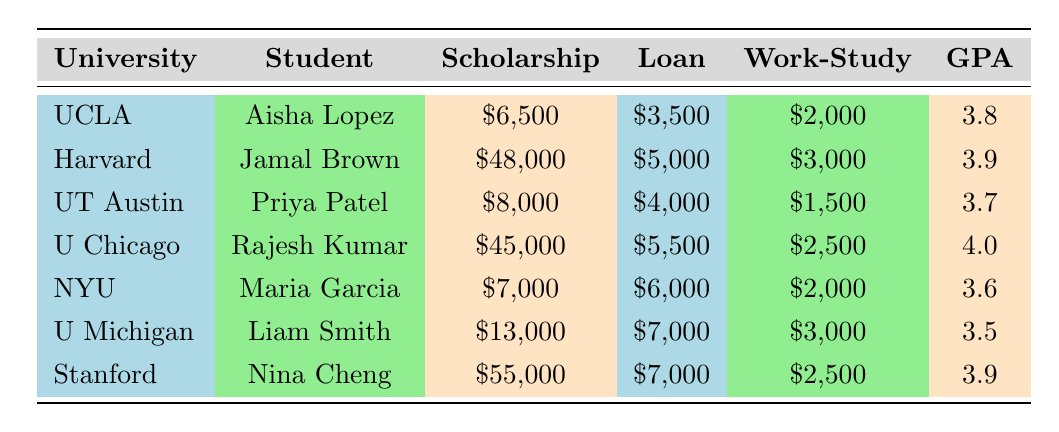What is the total amount of financial aid received by Jamal Brown? The total aid for Jamal Brown is listed in the table under the 'Total Aid' column. It states that he received $56,000.
Answer: 56000 Which student has the highest GPA? By examining the GPA column, Rajesh Kumar is listed with the highest GPA of 4.0.
Answer: Rajesh Kumar What is the average scholarship amount for the students listed in the table? The total scholarship amounts are $6,500 + $48,000 + $8,000 + $45,000 + $7,000 + $13,000 + $55,000 = $182,500. There are 7 students, so the average is $182,500 ÷ 7 = $26,071.43.
Answer: 26071.43 Is it true that all students have a GPA of 3.5 or higher? Checking the GPA column reveals that Liam Smith has a GPA of 3.5, and all other students have higher GPAs, so the statement is true.
Answer: Yes How much total financial aid was awarded to University of Michigan students compared to University of California, Los Angeles students? The total aid for UCLA students (Aisha Lopez) is $12,000. For University of Michigan (Liam Smith), the aid is $23,000. The difference is $23,000 - $12,000 = $11,000. Hence, University of Michigan received $11,000 more.
Answer: University of Michigan received $11,000 more 